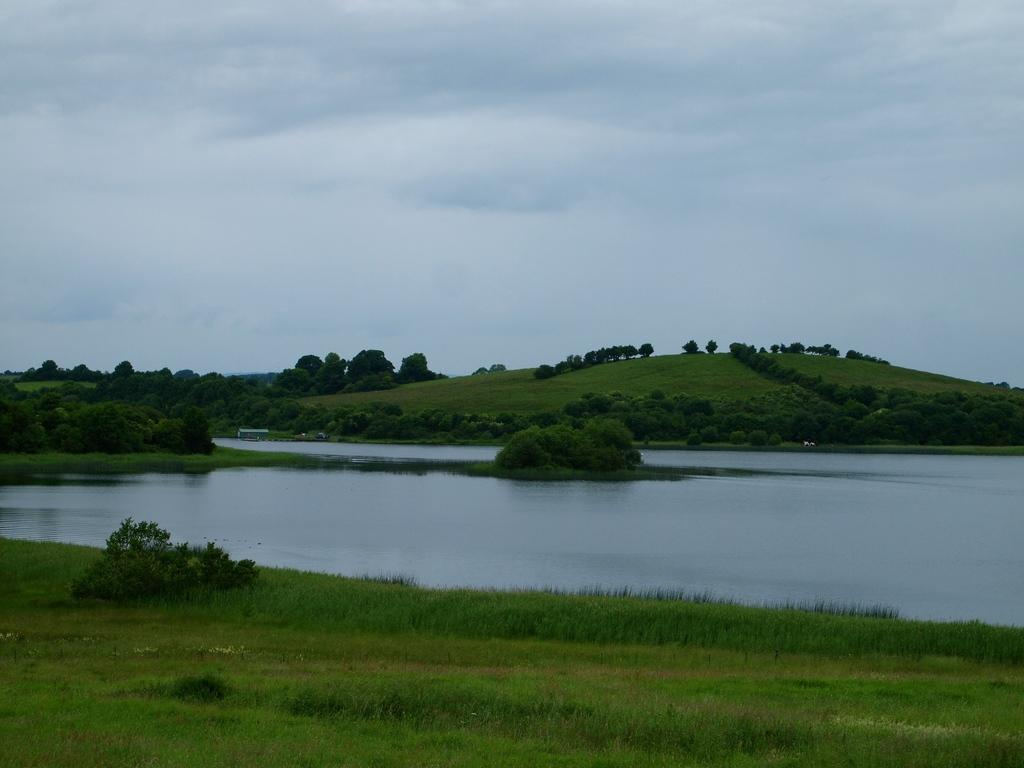What is one of the natural elements present in the image? There is water in the image. What type of vegetation can be seen in the image? There is grass, plants, and trees in the image. What part of the natural environment is visible in the background of the image? The sky is visible in the background of the image. What is the cause of the snow in the image? There is no snow present in the image; it features water, grass, plants, trees, and a visible sky. 